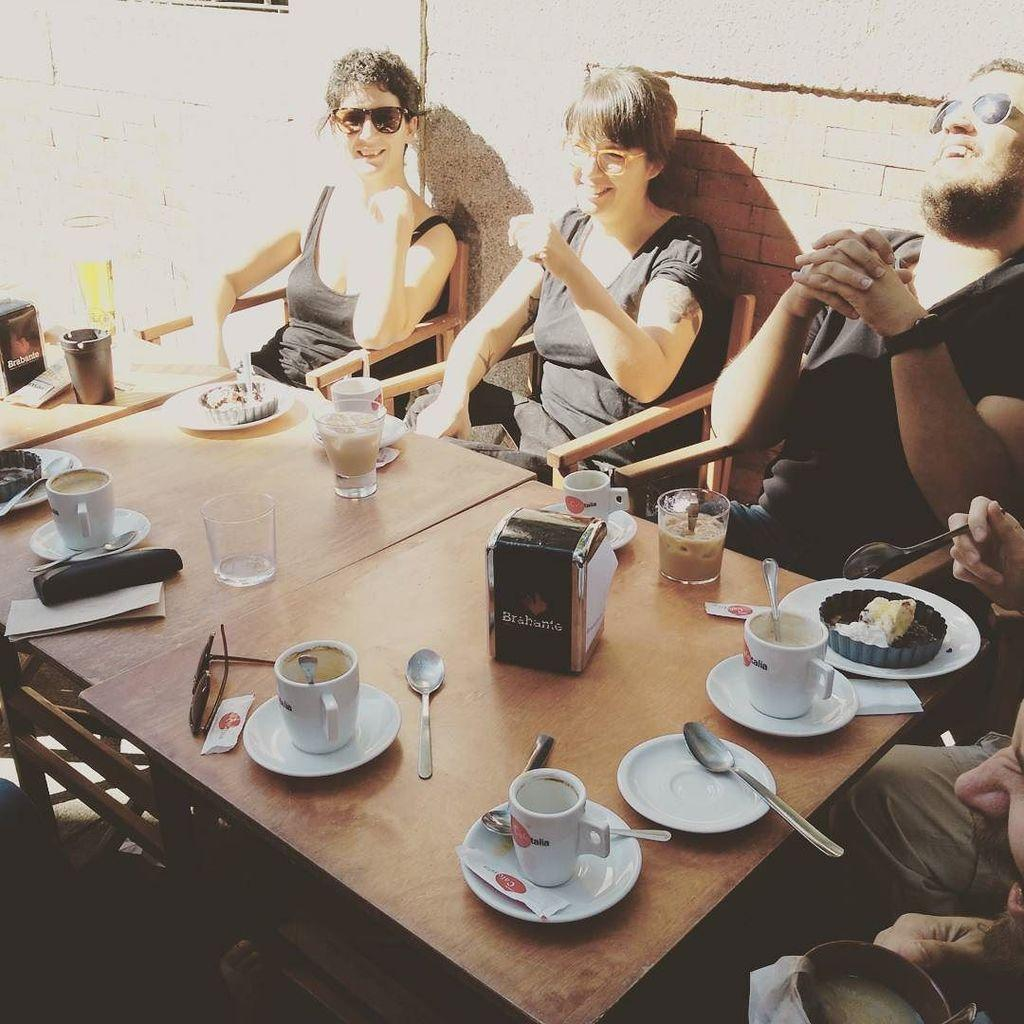What are the people in the image doing? The people in the image are sitting on chairs. What items can be seen on the tables in the image? There are plates, saucers, spoons, cups, and goggles on the tables in the image. What type of objects are present on the tables? The objects on the tables are plates, saucers, spoons, cups, and goggles. What is visible in the background of the image? There is a wall in the background of the image. What type of ear is visible on the goggles in the image? There are no ears visible in the image, as the goggles are not attached to a person's head. 